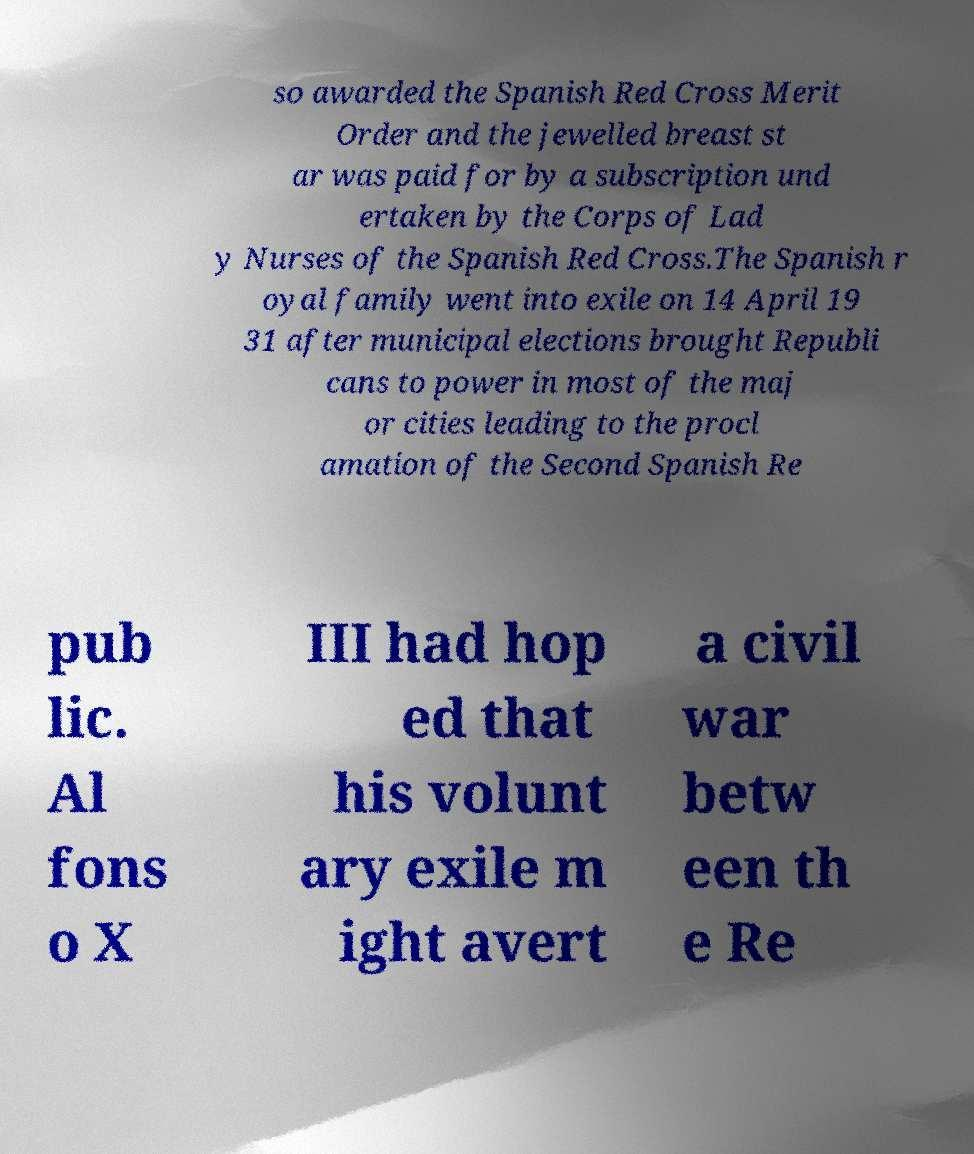There's text embedded in this image that I need extracted. Can you transcribe it verbatim? so awarded the Spanish Red Cross Merit Order and the jewelled breast st ar was paid for by a subscription und ertaken by the Corps of Lad y Nurses of the Spanish Red Cross.The Spanish r oyal family went into exile on 14 April 19 31 after municipal elections brought Republi cans to power in most of the maj or cities leading to the procl amation of the Second Spanish Re pub lic. Al fons o X III had hop ed that his volunt ary exile m ight avert a civil war betw een th e Re 